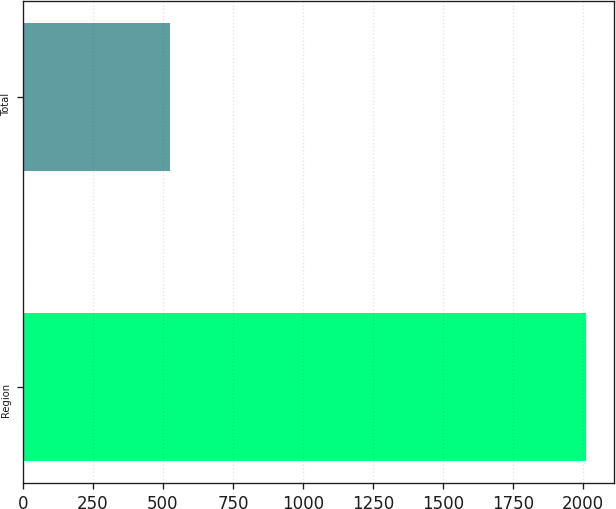Convert chart. <chart><loc_0><loc_0><loc_500><loc_500><bar_chart><fcel>Region<fcel>Total<nl><fcel>2011<fcel>524<nl></chart> 